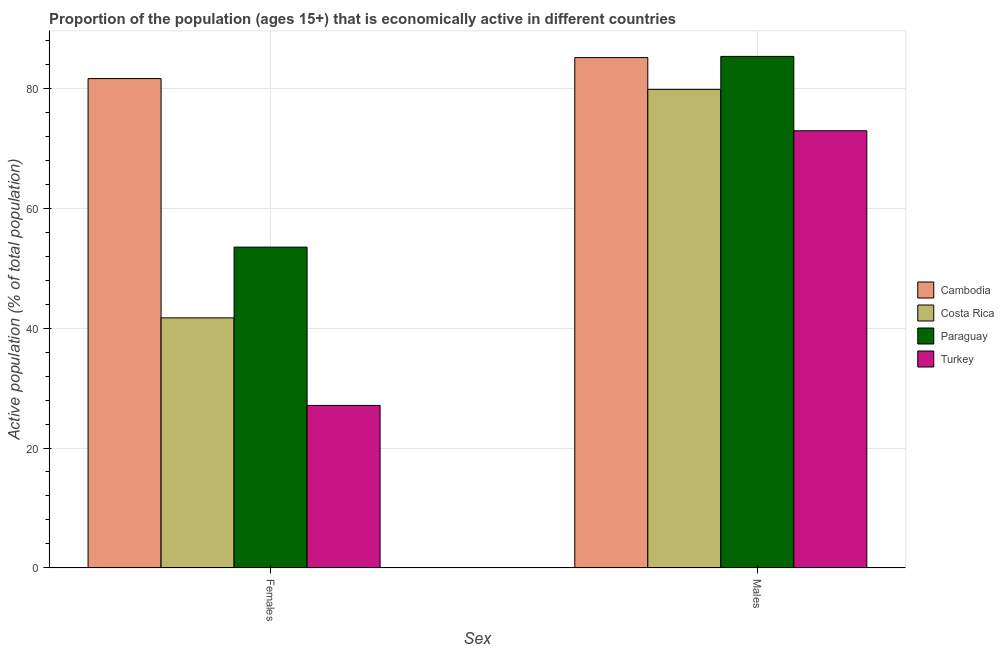Are the number of bars per tick equal to the number of legend labels?
Your answer should be very brief. Yes. How many bars are there on the 2nd tick from the left?
Your response must be concise. 4. How many bars are there on the 1st tick from the right?
Make the answer very short. 4. What is the label of the 1st group of bars from the left?
Ensure brevity in your answer.  Females. What is the percentage of economically active female population in Turkey?
Keep it short and to the point. 27.1. Across all countries, what is the maximum percentage of economically active male population?
Offer a very short reply. 85.3. Across all countries, what is the minimum percentage of economically active male population?
Your response must be concise. 72.9. In which country was the percentage of economically active female population maximum?
Your answer should be compact. Cambodia. What is the total percentage of economically active male population in the graph?
Provide a succinct answer. 323.1. What is the difference between the percentage of economically active male population in Paraguay and that in Cambodia?
Provide a succinct answer. 0.2. What is the difference between the percentage of economically active male population in Turkey and the percentage of economically active female population in Cambodia?
Offer a terse response. -8.7. What is the average percentage of economically active female population per country?
Your answer should be very brief. 50.97. What is the difference between the percentage of economically active female population and percentage of economically active male population in Costa Rica?
Your answer should be very brief. -38.1. What is the ratio of the percentage of economically active male population in Paraguay to that in Costa Rica?
Your answer should be very brief. 1.07. Is the percentage of economically active female population in Paraguay less than that in Costa Rica?
Make the answer very short. No. In how many countries, is the percentage of economically active male population greater than the average percentage of economically active male population taken over all countries?
Give a very brief answer. 2. What does the 1st bar from the left in Males represents?
Your answer should be compact. Cambodia. What does the 2nd bar from the right in Males represents?
Give a very brief answer. Paraguay. How many bars are there?
Offer a terse response. 8. How many countries are there in the graph?
Make the answer very short. 4. Are the values on the major ticks of Y-axis written in scientific E-notation?
Ensure brevity in your answer.  No. Does the graph contain grids?
Keep it short and to the point. Yes. How many legend labels are there?
Provide a succinct answer. 4. How are the legend labels stacked?
Ensure brevity in your answer.  Vertical. What is the title of the graph?
Make the answer very short. Proportion of the population (ages 15+) that is economically active in different countries. What is the label or title of the X-axis?
Your answer should be compact. Sex. What is the label or title of the Y-axis?
Your response must be concise. Active population (% of total population). What is the Active population (% of total population) in Cambodia in Females?
Keep it short and to the point. 81.6. What is the Active population (% of total population) in Costa Rica in Females?
Give a very brief answer. 41.7. What is the Active population (% of total population) in Paraguay in Females?
Your response must be concise. 53.5. What is the Active population (% of total population) of Turkey in Females?
Offer a very short reply. 27.1. What is the Active population (% of total population) of Cambodia in Males?
Keep it short and to the point. 85.1. What is the Active population (% of total population) in Costa Rica in Males?
Provide a short and direct response. 79.8. What is the Active population (% of total population) in Paraguay in Males?
Give a very brief answer. 85.3. What is the Active population (% of total population) of Turkey in Males?
Give a very brief answer. 72.9. Across all Sex, what is the maximum Active population (% of total population) in Cambodia?
Your response must be concise. 85.1. Across all Sex, what is the maximum Active population (% of total population) of Costa Rica?
Keep it short and to the point. 79.8. Across all Sex, what is the maximum Active population (% of total population) in Paraguay?
Ensure brevity in your answer.  85.3. Across all Sex, what is the maximum Active population (% of total population) in Turkey?
Provide a short and direct response. 72.9. Across all Sex, what is the minimum Active population (% of total population) of Cambodia?
Provide a succinct answer. 81.6. Across all Sex, what is the minimum Active population (% of total population) of Costa Rica?
Your answer should be very brief. 41.7. Across all Sex, what is the minimum Active population (% of total population) of Paraguay?
Give a very brief answer. 53.5. Across all Sex, what is the minimum Active population (% of total population) in Turkey?
Your response must be concise. 27.1. What is the total Active population (% of total population) of Cambodia in the graph?
Provide a short and direct response. 166.7. What is the total Active population (% of total population) in Costa Rica in the graph?
Provide a succinct answer. 121.5. What is the total Active population (% of total population) of Paraguay in the graph?
Your answer should be very brief. 138.8. What is the total Active population (% of total population) of Turkey in the graph?
Offer a very short reply. 100. What is the difference between the Active population (% of total population) of Cambodia in Females and that in Males?
Offer a very short reply. -3.5. What is the difference between the Active population (% of total population) in Costa Rica in Females and that in Males?
Give a very brief answer. -38.1. What is the difference between the Active population (% of total population) of Paraguay in Females and that in Males?
Keep it short and to the point. -31.8. What is the difference between the Active population (% of total population) of Turkey in Females and that in Males?
Offer a terse response. -45.8. What is the difference between the Active population (% of total population) in Cambodia in Females and the Active population (% of total population) in Paraguay in Males?
Offer a terse response. -3.7. What is the difference between the Active population (% of total population) in Cambodia in Females and the Active population (% of total population) in Turkey in Males?
Provide a short and direct response. 8.7. What is the difference between the Active population (% of total population) in Costa Rica in Females and the Active population (% of total population) in Paraguay in Males?
Provide a succinct answer. -43.6. What is the difference between the Active population (% of total population) in Costa Rica in Females and the Active population (% of total population) in Turkey in Males?
Ensure brevity in your answer.  -31.2. What is the difference between the Active population (% of total population) of Paraguay in Females and the Active population (% of total population) of Turkey in Males?
Your answer should be very brief. -19.4. What is the average Active population (% of total population) of Cambodia per Sex?
Provide a succinct answer. 83.35. What is the average Active population (% of total population) of Costa Rica per Sex?
Make the answer very short. 60.75. What is the average Active population (% of total population) in Paraguay per Sex?
Offer a very short reply. 69.4. What is the average Active population (% of total population) in Turkey per Sex?
Offer a terse response. 50. What is the difference between the Active population (% of total population) in Cambodia and Active population (% of total population) in Costa Rica in Females?
Provide a succinct answer. 39.9. What is the difference between the Active population (% of total population) of Cambodia and Active population (% of total population) of Paraguay in Females?
Offer a very short reply. 28.1. What is the difference between the Active population (% of total population) of Cambodia and Active population (% of total population) of Turkey in Females?
Make the answer very short. 54.5. What is the difference between the Active population (% of total population) in Paraguay and Active population (% of total population) in Turkey in Females?
Your response must be concise. 26.4. What is the difference between the Active population (% of total population) in Cambodia and Active population (% of total population) in Costa Rica in Males?
Your answer should be compact. 5.3. What is the difference between the Active population (% of total population) of Cambodia and Active population (% of total population) of Turkey in Males?
Keep it short and to the point. 12.2. What is the difference between the Active population (% of total population) of Paraguay and Active population (% of total population) of Turkey in Males?
Provide a succinct answer. 12.4. What is the ratio of the Active population (% of total population) in Cambodia in Females to that in Males?
Provide a succinct answer. 0.96. What is the ratio of the Active population (% of total population) in Costa Rica in Females to that in Males?
Your answer should be very brief. 0.52. What is the ratio of the Active population (% of total population) in Paraguay in Females to that in Males?
Your answer should be very brief. 0.63. What is the ratio of the Active population (% of total population) of Turkey in Females to that in Males?
Your answer should be compact. 0.37. What is the difference between the highest and the second highest Active population (% of total population) in Cambodia?
Make the answer very short. 3.5. What is the difference between the highest and the second highest Active population (% of total population) of Costa Rica?
Ensure brevity in your answer.  38.1. What is the difference between the highest and the second highest Active population (% of total population) in Paraguay?
Keep it short and to the point. 31.8. What is the difference between the highest and the second highest Active population (% of total population) of Turkey?
Your answer should be compact. 45.8. What is the difference between the highest and the lowest Active population (% of total population) of Cambodia?
Provide a succinct answer. 3.5. What is the difference between the highest and the lowest Active population (% of total population) in Costa Rica?
Give a very brief answer. 38.1. What is the difference between the highest and the lowest Active population (% of total population) of Paraguay?
Ensure brevity in your answer.  31.8. What is the difference between the highest and the lowest Active population (% of total population) of Turkey?
Offer a terse response. 45.8. 